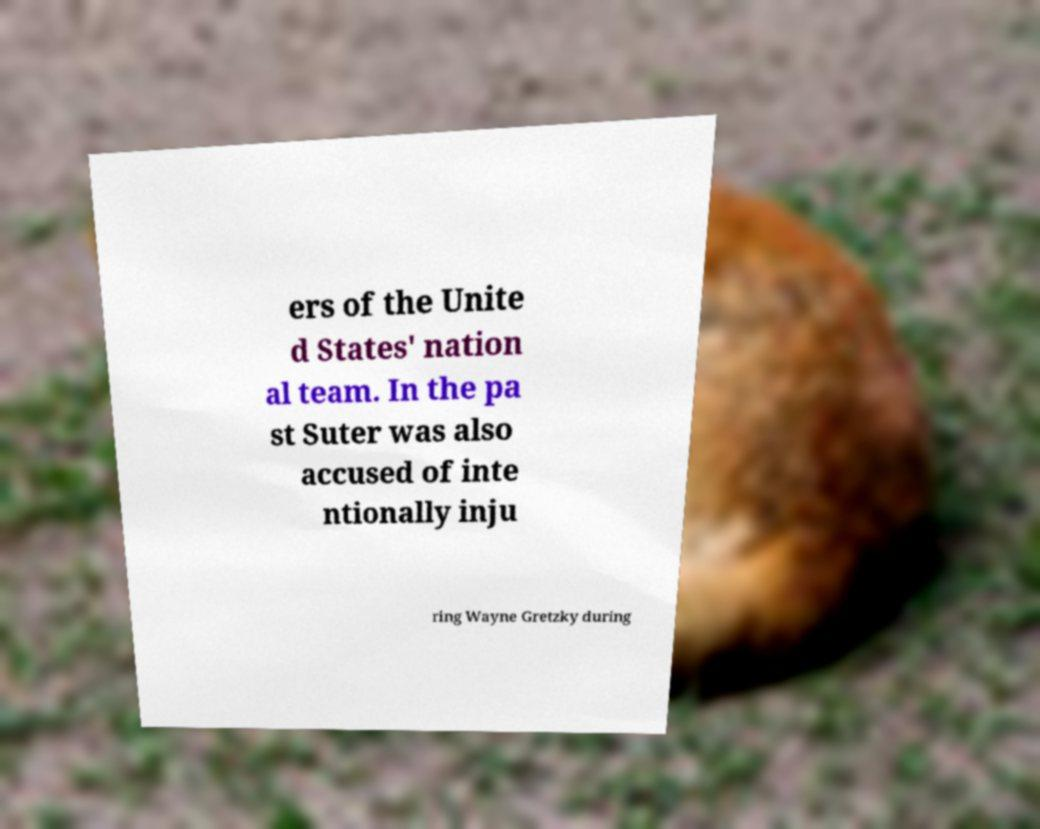Can you read and provide the text displayed in the image?This photo seems to have some interesting text. Can you extract and type it out for me? ers of the Unite d States' nation al team. In the pa st Suter was also accused of inte ntionally inju ring Wayne Gretzky during 